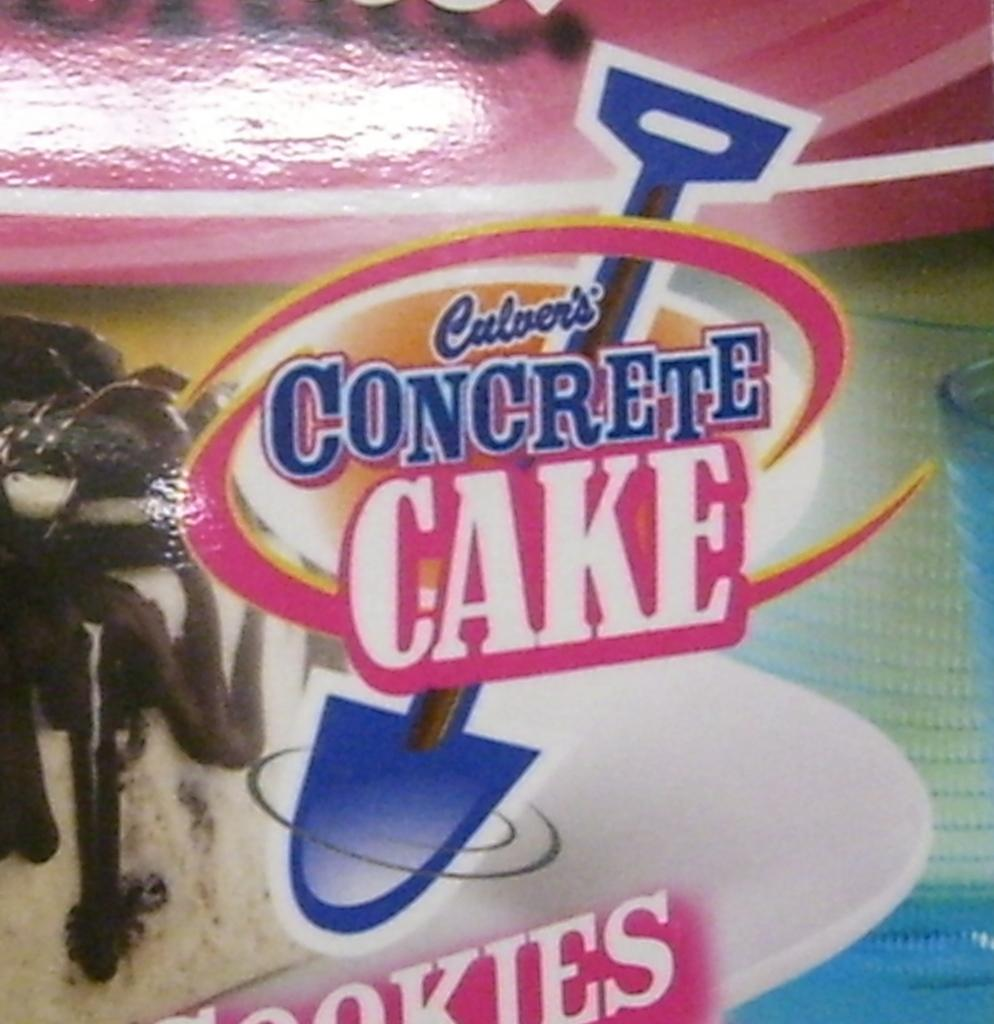What is the main object in the image? There is a wrapper of a packed food in the image. What type of cast can be seen on the person's arm in the image? There is no person or cast present in the image; it only features a wrapper of a packed food. 